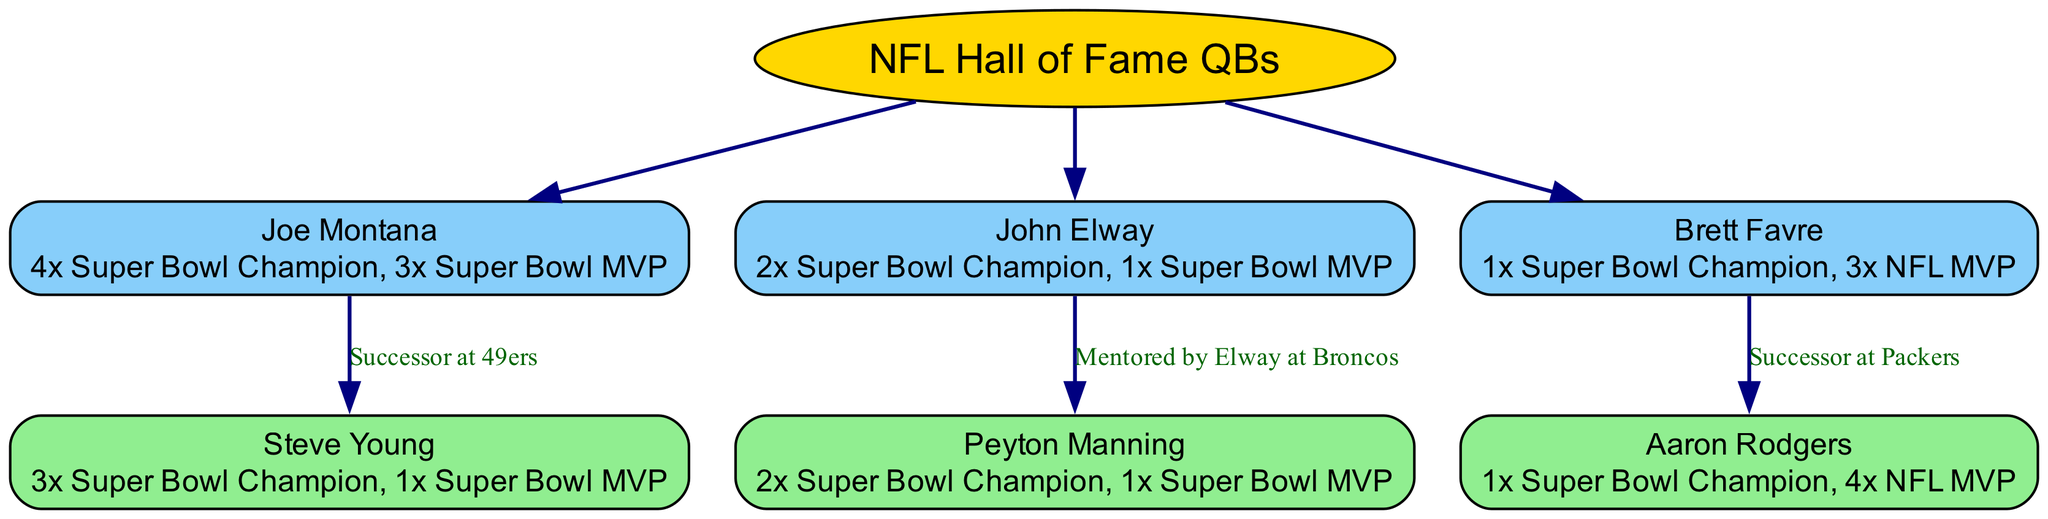What is the root of the family tree? The root node in the diagram is labeled "NFL Hall of Fame QBs," which represents the primary category or starting point of the family tree.
Answer: NFL Hall of Fame QBs How many children does Joe Montana have? Joe Montana has one child listed in the diagram, which is Steve Young, making it a total of one child under his branch.
Answer: 1 What is Peyton Manning's relationship with John Elway? In the diagram, the relationship is specified as "Mentored by Elway at Broncos," indicating a direct mentorship connection between John Elway and Peyton Manning.
Answer: Mentored by Elway at Broncos Which player has the most NFL MVP awards? Aaron Rodgers is listed with 4 NFL MVP awards, which is the highest number among the quarterbacks shown in the diagram.
Answer: 4 NFL MVP Who succeeded Joe Montana at the 49ers? The diagram indicates that Steve Young succeeded Joe Montana at the San Francisco 49ers, making him the successor to Joe Montana in that team role.
Answer: Steve Young What are the total Super Bowl championships among the quarterbacks in the tree? The total Super Bowl championships can be calculated by adding the championships: Joe Montana (4) + Steve Young (3) + John Elway (2) + Peyton Manning (2) + Brett Favre (1) + Aaron Rodgers (1) = 13 Super Bowl championships in total.
Answer: 13 Super Bowl championships Which quarterback has the highest number of Super Bowl MVP awards? Joe Montana has been named Super Bowl MVP three times, which is the highest count presented among the quarterbacks in the diagram.
Answer: 3 Super Bowl MVP What is the relationship between Brett Favre and Aaron Rodgers? The diagram depicts Aaron Rodgers as the "Successor at Packers," indicating a direct lineage where Rodgers followed Favre in the quarterback position for the Packers.
Answer: Successor at Packers 